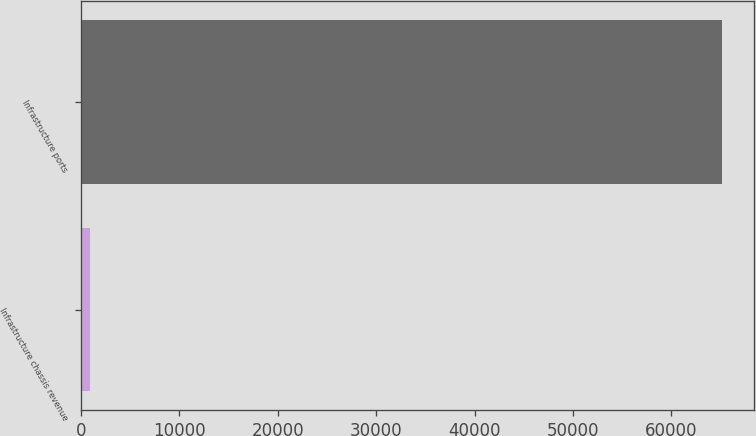<chart> <loc_0><loc_0><loc_500><loc_500><bar_chart><fcel>Infrastructure chassis revenue<fcel>Infrastructure ports<nl><fcel>984<fcel>65134<nl></chart> 